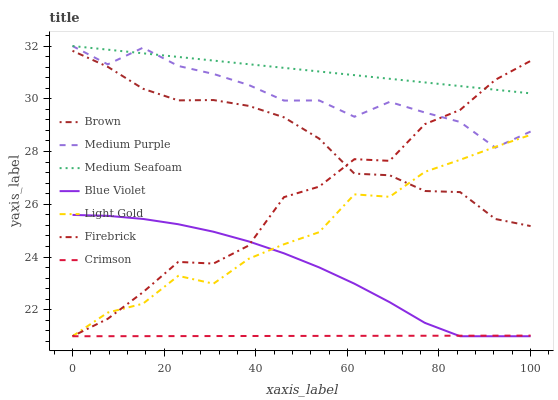Does Crimson have the minimum area under the curve?
Answer yes or no. Yes. Does Medium Seafoam have the maximum area under the curve?
Answer yes or no. Yes. Does Firebrick have the minimum area under the curve?
Answer yes or no. No. Does Firebrick have the maximum area under the curve?
Answer yes or no. No. Is Medium Seafoam the smoothest?
Answer yes or no. Yes. Is Firebrick the roughest?
Answer yes or no. Yes. Is Medium Purple the smoothest?
Answer yes or no. No. Is Medium Purple the roughest?
Answer yes or no. No. Does Firebrick have the lowest value?
Answer yes or no. Yes. Does Medium Purple have the lowest value?
Answer yes or no. No. Does Medium Seafoam have the highest value?
Answer yes or no. Yes. Does Firebrick have the highest value?
Answer yes or no. No. Is Light Gold less than Medium Seafoam?
Answer yes or no. Yes. Is Brown greater than Crimson?
Answer yes or no. Yes. Does Blue Violet intersect Light Gold?
Answer yes or no. Yes. Is Blue Violet less than Light Gold?
Answer yes or no. No. Is Blue Violet greater than Light Gold?
Answer yes or no. No. Does Light Gold intersect Medium Seafoam?
Answer yes or no. No. 